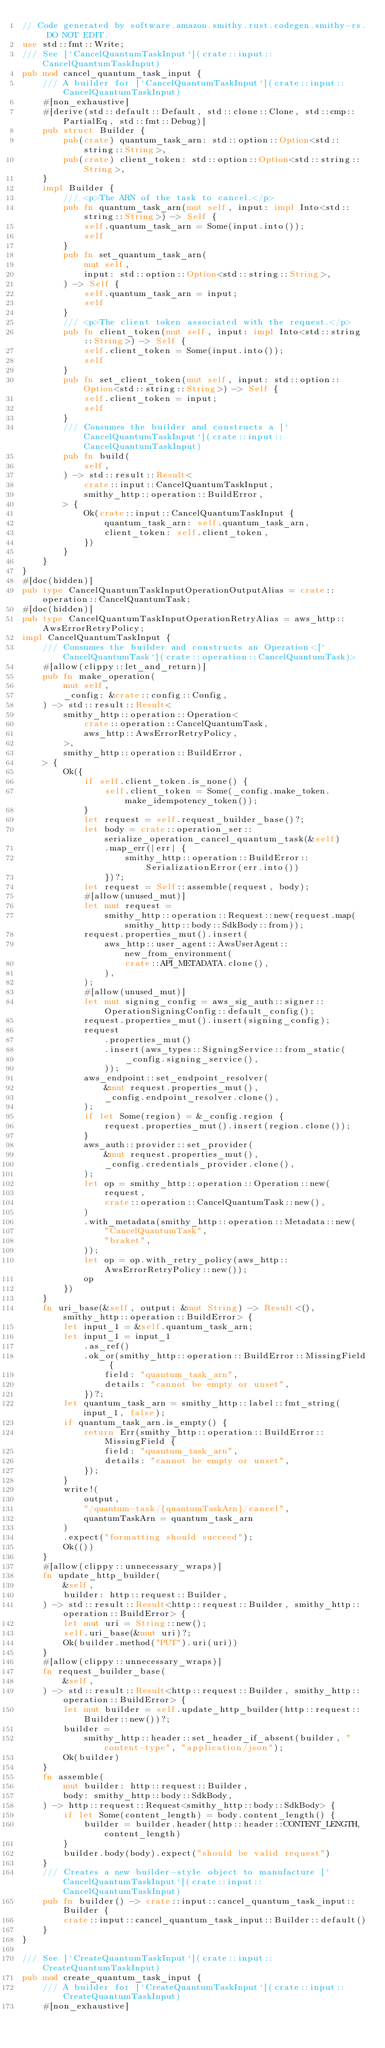<code> <loc_0><loc_0><loc_500><loc_500><_Rust_>// Code generated by software.amazon.smithy.rust.codegen.smithy-rs. DO NOT EDIT.
use std::fmt::Write;
/// See [`CancelQuantumTaskInput`](crate::input::CancelQuantumTaskInput)
pub mod cancel_quantum_task_input {
    /// A builder for [`CancelQuantumTaskInput`](crate::input::CancelQuantumTaskInput)
    #[non_exhaustive]
    #[derive(std::default::Default, std::clone::Clone, std::cmp::PartialEq, std::fmt::Debug)]
    pub struct Builder {
        pub(crate) quantum_task_arn: std::option::Option<std::string::String>,
        pub(crate) client_token: std::option::Option<std::string::String>,
    }
    impl Builder {
        /// <p>The ARN of the task to cancel.</p>
        pub fn quantum_task_arn(mut self, input: impl Into<std::string::String>) -> Self {
            self.quantum_task_arn = Some(input.into());
            self
        }
        pub fn set_quantum_task_arn(
            mut self,
            input: std::option::Option<std::string::String>,
        ) -> Self {
            self.quantum_task_arn = input;
            self
        }
        /// <p>The client token associated with the request.</p>
        pub fn client_token(mut self, input: impl Into<std::string::String>) -> Self {
            self.client_token = Some(input.into());
            self
        }
        pub fn set_client_token(mut self, input: std::option::Option<std::string::String>) -> Self {
            self.client_token = input;
            self
        }
        /// Consumes the builder and constructs a [`CancelQuantumTaskInput`](crate::input::CancelQuantumTaskInput)
        pub fn build(
            self,
        ) -> std::result::Result<
            crate::input::CancelQuantumTaskInput,
            smithy_http::operation::BuildError,
        > {
            Ok(crate::input::CancelQuantumTaskInput {
                quantum_task_arn: self.quantum_task_arn,
                client_token: self.client_token,
            })
        }
    }
}
#[doc(hidden)]
pub type CancelQuantumTaskInputOperationOutputAlias = crate::operation::CancelQuantumTask;
#[doc(hidden)]
pub type CancelQuantumTaskInputOperationRetryAlias = aws_http::AwsErrorRetryPolicy;
impl CancelQuantumTaskInput {
    /// Consumes the builder and constructs an Operation<[`CancelQuantumTask`](crate::operation::CancelQuantumTask)>
    #[allow(clippy::let_and_return)]
    pub fn make_operation(
        mut self,
        _config: &crate::config::Config,
    ) -> std::result::Result<
        smithy_http::operation::Operation<
            crate::operation::CancelQuantumTask,
            aws_http::AwsErrorRetryPolicy,
        >,
        smithy_http::operation::BuildError,
    > {
        Ok({
            if self.client_token.is_none() {
                self.client_token = Some(_config.make_token.make_idempotency_token());
            }
            let request = self.request_builder_base()?;
            let body = crate::operation_ser::serialize_operation_cancel_quantum_task(&self)
                .map_err(|err| {
                    smithy_http::operation::BuildError::SerializationError(err.into())
                })?;
            let request = Self::assemble(request, body);
            #[allow(unused_mut)]
            let mut request =
                smithy_http::operation::Request::new(request.map(smithy_http::body::SdkBody::from));
            request.properties_mut().insert(
                aws_http::user_agent::AwsUserAgent::new_from_environment(
                    crate::API_METADATA.clone(),
                ),
            );
            #[allow(unused_mut)]
            let mut signing_config = aws_sig_auth::signer::OperationSigningConfig::default_config();
            request.properties_mut().insert(signing_config);
            request
                .properties_mut()
                .insert(aws_types::SigningService::from_static(
                    _config.signing_service(),
                ));
            aws_endpoint::set_endpoint_resolver(
                &mut request.properties_mut(),
                _config.endpoint_resolver.clone(),
            );
            if let Some(region) = &_config.region {
                request.properties_mut().insert(region.clone());
            }
            aws_auth::provider::set_provider(
                &mut request.properties_mut(),
                _config.credentials_provider.clone(),
            );
            let op = smithy_http::operation::Operation::new(
                request,
                crate::operation::CancelQuantumTask::new(),
            )
            .with_metadata(smithy_http::operation::Metadata::new(
                "CancelQuantumTask",
                "braket",
            ));
            let op = op.with_retry_policy(aws_http::AwsErrorRetryPolicy::new());
            op
        })
    }
    fn uri_base(&self, output: &mut String) -> Result<(), smithy_http::operation::BuildError> {
        let input_1 = &self.quantum_task_arn;
        let input_1 = input_1
            .as_ref()
            .ok_or(smithy_http::operation::BuildError::MissingField {
                field: "quantum_task_arn",
                details: "cannot be empty or unset",
            })?;
        let quantum_task_arn = smithy_http::label::fmt_string(input_1, false);
        if quantum_task_arn.is_empty() {
            return Err(smithy_http::operation::BuildError::MissingField {
                field: "quantum_task_arn",
                details: "cannot be empty or unset",
            });
        }
        write!(
            output,
            "/quantum-task/{quantumTaskArn}/cancel",
            quantumTaskArn = quantum_task_arn
        )
        .expect("formatting should succeed");
        Ok(())
    }
    #[allow(clippy::unnecessary_wraps)]
    fn update_http_builder(
        &self,
        builder: http::request::Builder,
    ) -> std::result::Result<http::request::Builder, smithy_http::operation::BuildError> {
        let mut uri = String::new();
        self.uri_base(&mut uri)?;
        Ok(builder.method("PUT").uri(uri))
    }
    #[allow(clippy::unnecessary_wraps)]
    fn request_builder_base(
        &self,
    ) -> std::result::Result<http::request::Builder, smithy_http::operation::BuildError> {
        let mut builder = self.update_http_builder(http::request::Builder::new())?;
        builder =
            smithy_http::header::set_header_if_absent(builder, "content-type", "application/json");
        Ok(builder)
    }
    fn assemble(
        mut builder: http::request::Builder,
        body: smithy_http::body::SdkBody,
    ) -> http::request::Request<smithy_http::body::SdkBody> {
        if let Some(content_length) = body.content_length() {
            builder = builder.header(http::header::CONTENT_LENGTH, content_length)
        }
        builder.body(body).expect("should be valid request")
    }
    /// Creates a new builder-style object to manufacture [`CancelQuantumTaskInput`](crate::input::CancelQuantumTaskInput)
    pub fn builder() -> crate::input::cancel_quantum_task_input::Builder {
        crate::input::cancel_quantum_task_input::Builder::default()
    }
}

/// See [`CreateQuantumTaskInput`](crate::input::CreateQuantumTaskInput)
pub mod create_quantum_task_input {
    /// A builder for [`CreateQuantumTaskInput`](crate::input::CreateQuantumTaskInput)
    #[non_exhaustive]</code> 